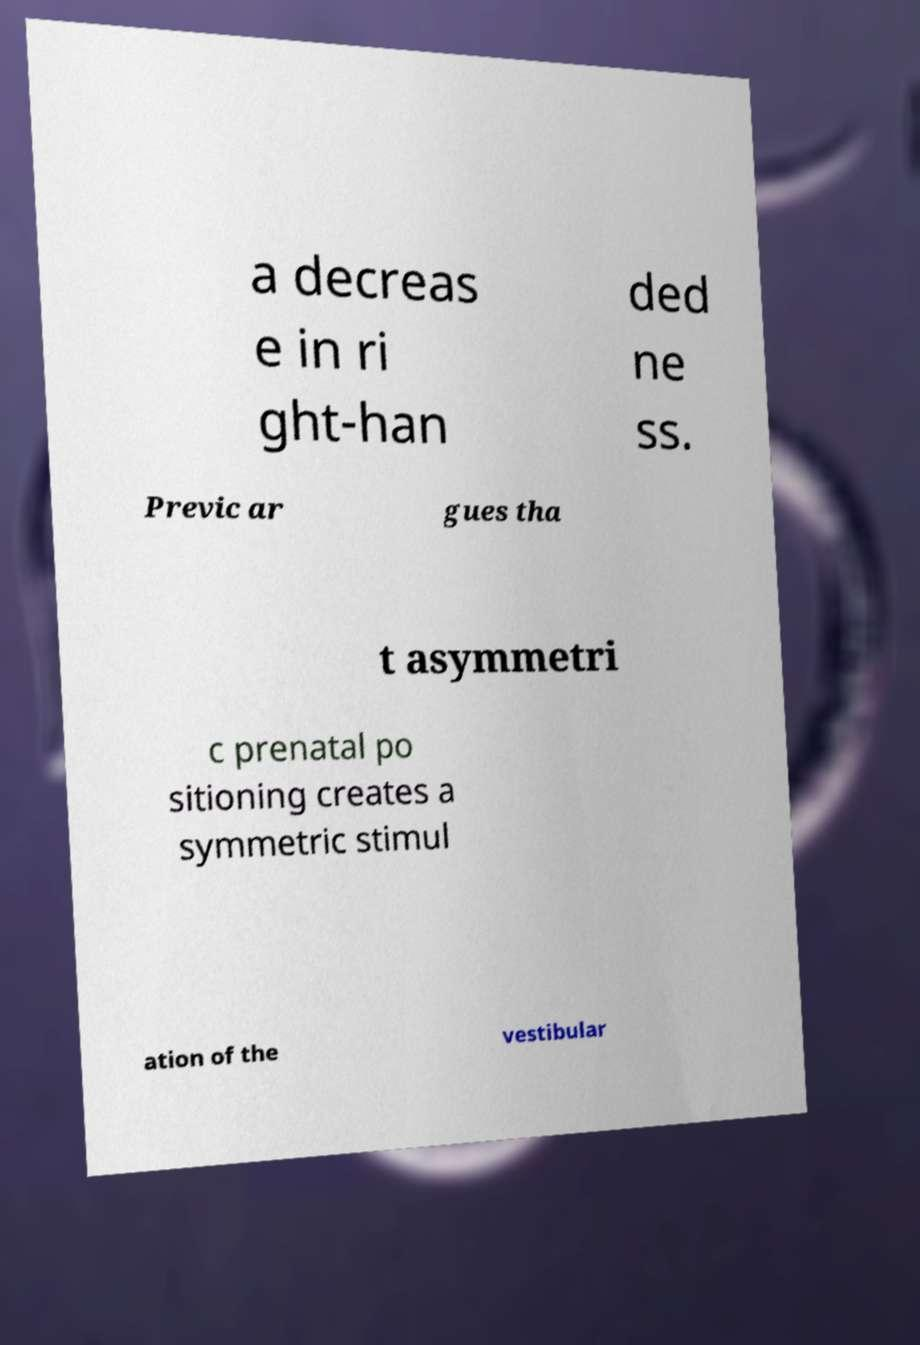I need the written content from this picture converted into text. Can you do that? a decreas e in ri ght-han ded ne ss. Previc ar gues tha t asymmetri c prenatal po sitioning creates a symmetric stimul ation of the vestibular 